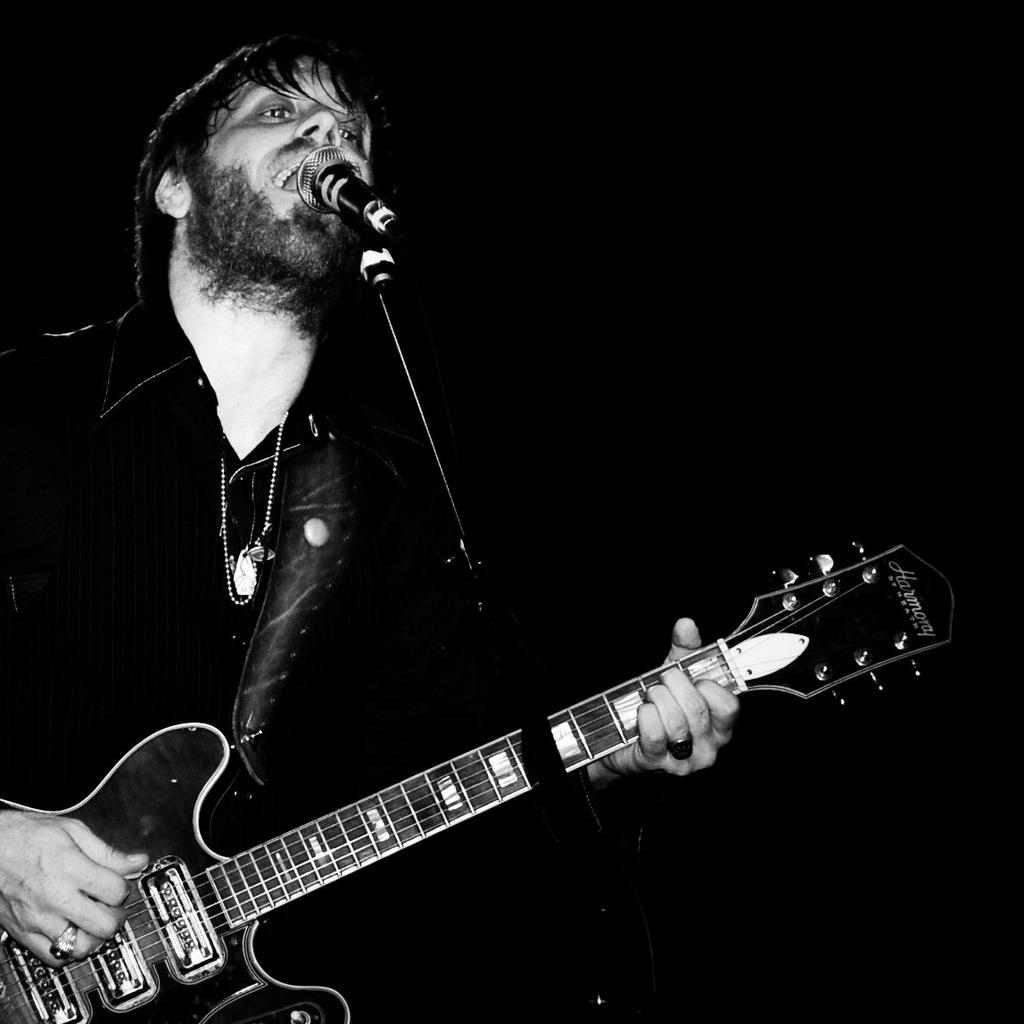What is the man in the image doing? The man is singing and playing a guitar. What object is the man holding while singing? The man is holding a microphone. Can you describe the background of the image? The background of the image is completely dark. What type of nail is the man using to play the guitar in the image? There is no nail visible in the image, and the man is not using a nail to play the guitar. What kind of pies can be seen on the table in the image? There is no table or pies present in the image. 